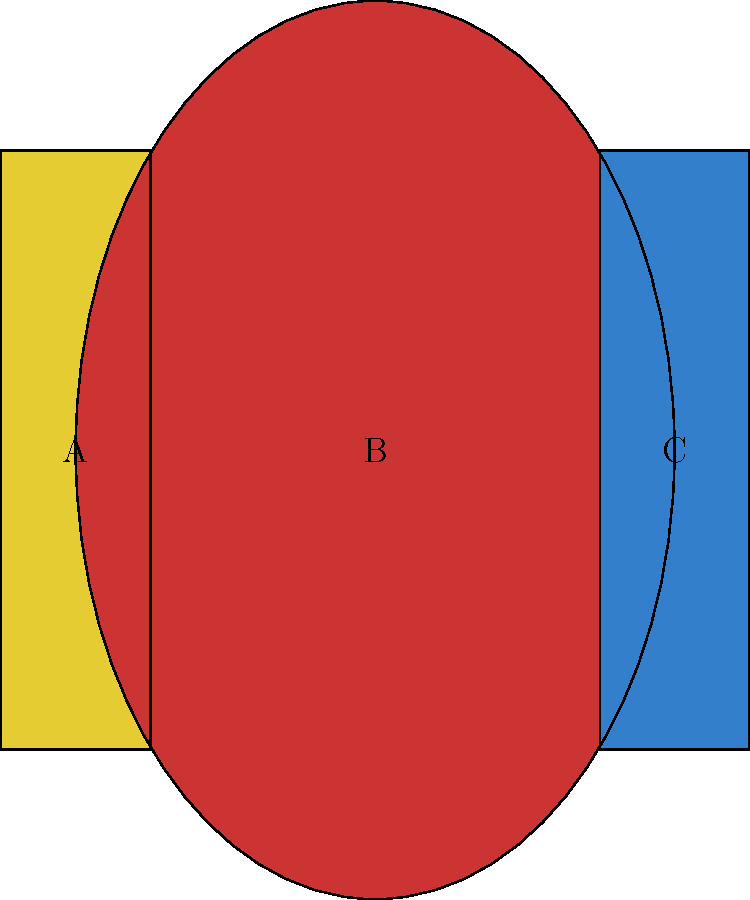Identify the Orthodox clergy vestments labeled A, B, and C in the image above. Which of these is worn by priests, deacons, and bishops alike during liturgical services? To answer this question, let's examine each vestment:

1. Vestment A: This is the stole, also known as the orarion. It is a long, narrow strip of cloth worn by deacons over the left shoulder.

2. Vestment B: This is the chasuble, also called the phelonion. It is a large, poncho-like garment worn by priests over all other vestments during the Divine Liturgy.

3. Vestment C: This is the epitrachelion, which is a stole worn by priests and bishops. It hangs down in front and is worn under the chasuble.

Among these three vestments, only the epitrachelion (C) is worn by priests, deacons, and bishops alike during liturgical services. 

- Priests wear the epitrachelion for all services.
- Bishops wear the epitrachelion as part of their liturgical attire.
- Deacons wear a modified form of the epitrachelion called the orarion.

The stole (A) is specific to deacons, while the chasuble (B) is worn only by priests during the Divine Liturgy. Therefore, the epitrachelion (C) is the correct answer as it is common to all three ranks of clergy.
Answer: Epitrachelion (C) 